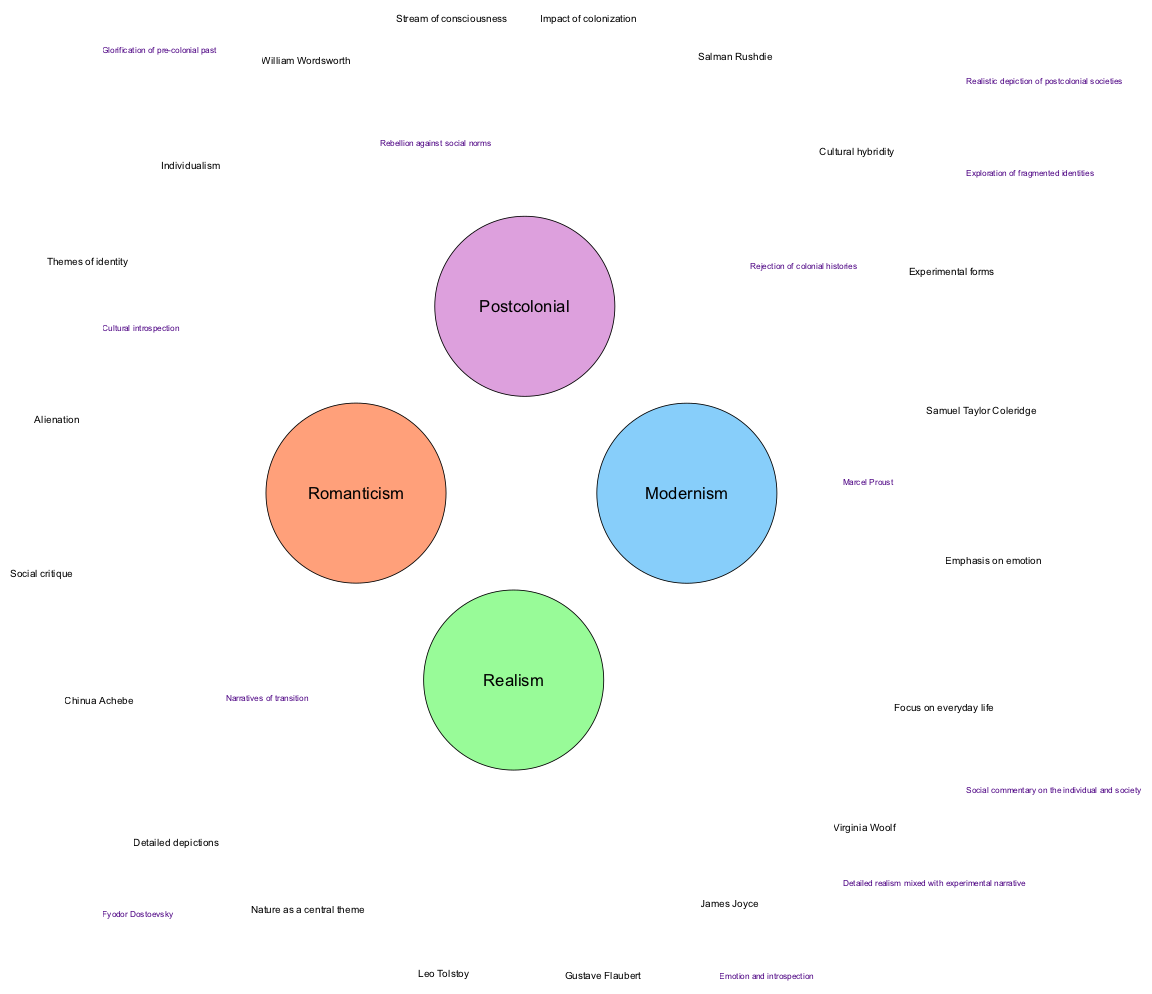What are the five elements associated with Romanticism? The diagram lists the elements of Romanticism, which are located in the corresponding circle. They include: "Emphasis on emotion," "Nature as a central theme," "William Wordsworth," "Samuel Taylor Coleridge," and "Individualism."
Answer: Emphasis on emotion, Nature as a central theme, William Wordsworth, Samuel Taylor Coleridge, Individualism Which author is associated with both Realism and Modernism? The intersection between Realism and Modernism in the diagram points to the author "Marcel Proust," who embodies elements of both literary movements.
Answer: Marcel Proust How many literary movements are represented in the diagram? The diagram contains four distinct circles representing the literary movements: Romanticism, Realism, Modernism, and Postcolonial. Thus, the total number of movements is four.
Answer: 4 What themes are common to both Modernism and Postcolonial literature? The intersection between Modernism and Postcolonial reveals themes that include "Rejection of colonial histories" and "Exploration of fragmented identities," demonstrating the overlap between the two movements.
Answer: Rejection of colonial histories, Exploration of fragmented identities Which circle contains the theme of "Cultural hybridity"? The diagram indicates that the theme "Cultural hybridity" is a specific element listed within the Postcolonial circle, highlighting its significance to that literary movement.
Answer: Postcolonial What does the overlap between Romanticism and Postcolonial literature suggest? The overlap shows that both movements share themes such as "Glorification of pre-colonial past" and "Cultural introspection," indicating a mutual interest in the impact of history on identity and culture.
Answer: Glorification of pre-colonial past, Cultural introspection Which element uniquely identifies the intersection of Romanticism and Realism? The unique elements that connect Romanticism and Realism involve social commentary, specifically articulated through the presence of "Fyodor Dostoevsky," who merges these two literary traditions.
Answer: Fyodor Dostoevsky What is the primary focus of Realism as depicted in the diagram? Realism, as shown in the diagram, primarily focuses on "Everyday life" and promotes "Detailed depictions," emphasizing a more realistic portrayal of the human experience.
Answer: Everyday life, Detailed depictions 